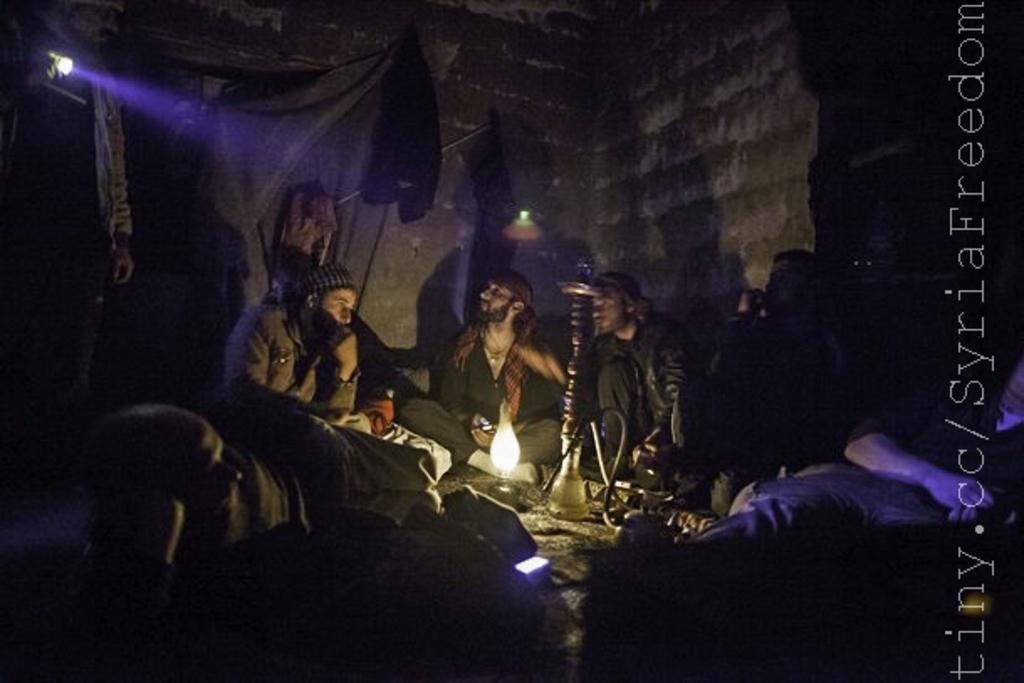In one or two sentences, can you explain what this image depicts? In this image we can see some persons sitting, in front the persons there is a lamp and in the background there is a wall with a light. 